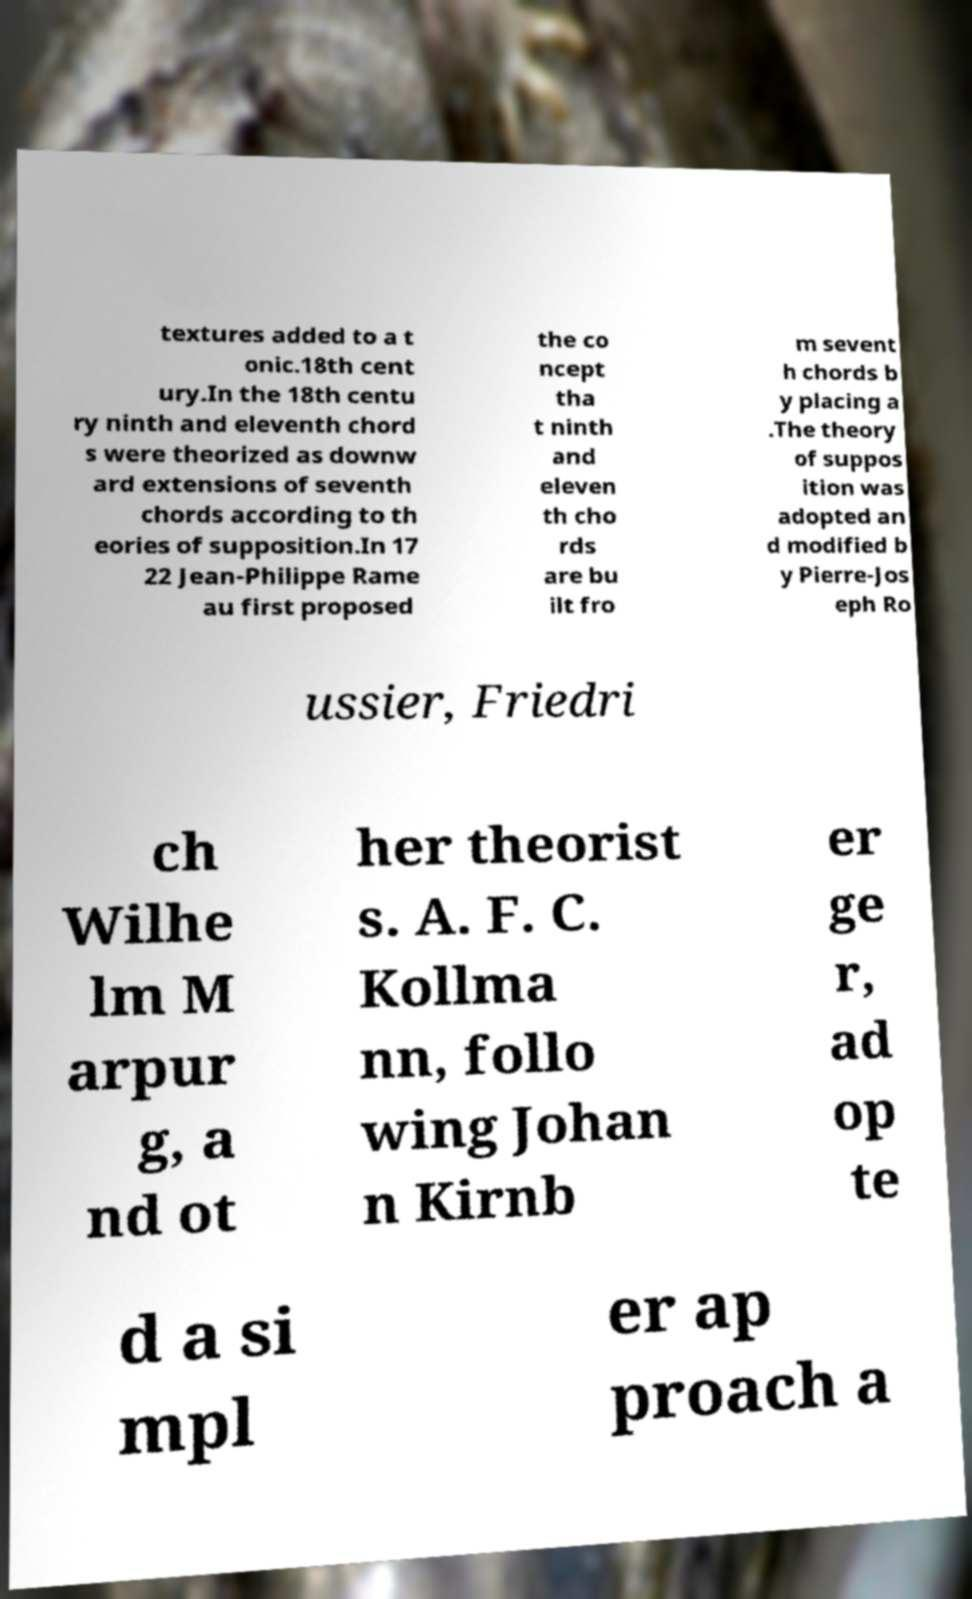Please identify and transcribe the text found in this image. textures added to a t onic.18th cent ury.In the 18th centu ry ninth and eleventh chord s were theorized as downw ard extensions of seventh chords according to th eories of supposition.In 17 22 Jean-Philippe Rame au first proposed the co ncept tha t ninth and eleven th cho rds are bu ilt fro m sevent h chords b y placing a .The theory of suppos ition was adopted an d modified b y Pierre-Jos eph Ro ussier, Friedri ch Wilhe lm M arpur g, a nd ot her theorist s. A. F. C. Kollma nn, follo wing Johan n Kirnb er ge r, ad op te d a si mpl er ap proach a 